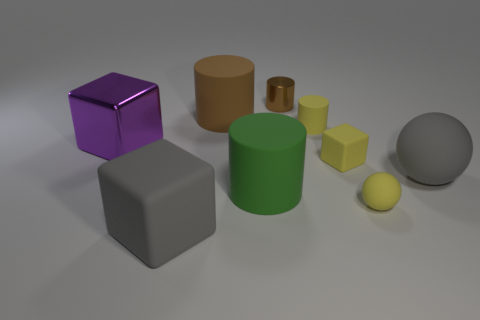Subtract all tiny yellow rubber cylinders. How many cylinders are left? 3 Subtract 1 balls. How many balls are left? 1 Subtract all gray spheres. How many spheres are left? 1 Subtract all blue spheres. How many gray cubes are left? 1 Subtract all big purple metallic cylinders. Subtract all tiny balls. How many objects are left? 8 Add 2 large matte balls. How many large matte balls are left? 3 Add 8 tiny gray metal blocks. How many tiny gray metal blocks exist? 8 Add 1 large shiny things. How many objects exist? 10 Subtract 0 brown spheres. How many objects are left? 9 Subtract all cubes. How many objects are left? 6 